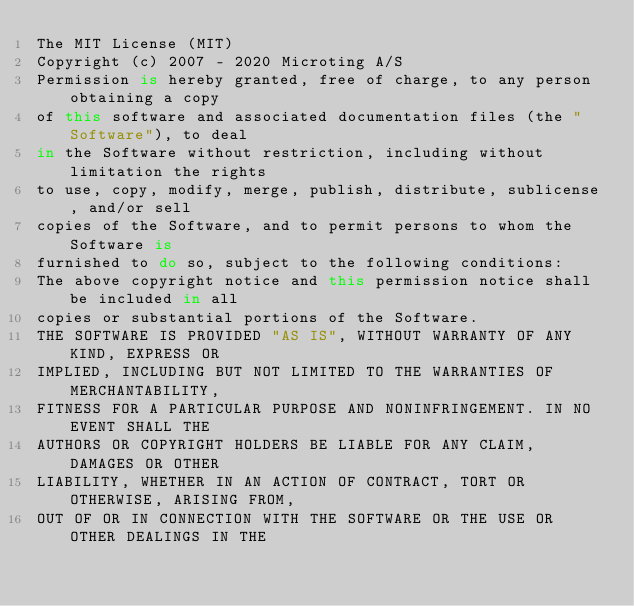<code> <loc_0><loc_0><loc_500><loc_500><_C#_>The MIT License (MIT)
Copyright (c) 2007 - 2020 Microting A/S
Permission is hereby granted, free of charge, to any person obtaining a copy
of this software and associated documentation files (the "Software"), to deal
in the Software without restriction, including without limitation the rights
to use, copy, modify, merge, publish, distribute, sublicense, and/or sell
copies of the Software, and to permit persons to whom the Software is
furnished to do so, subject to the following conditions:
The above copyright notice and this permission notice shall be included in all
copies or substantial portions of the Software.
THE SOFTWARE IS PROVIDED "AS IS", WITHOUT WARRANTY OF ANY KIND, EXPRESS OR
IMPLIED, INCLUDING BUT NOT LIMITED TO THE WARRANTIES OF MERCHANTABILITY,
FITNESS FOR A PARTICULAR PURPOSE AND NONINFRINGEMENT. IN NO EVENT SHALL THE
AUTHORS OR COPYRIGHT HOLDERS BE LIABLE FOR ANY CLAIM, DAMAGES OR OTHER
LIABILITY, WHETHER IN AN ACTION OF CONTRACT, TORT OR OTHERWISE, ARISING FROM,
OUT OF OR IN CONNECTION WITH THE SOFTWARE OR THE USE OR OTHER DEALINGS IN THE</code> 